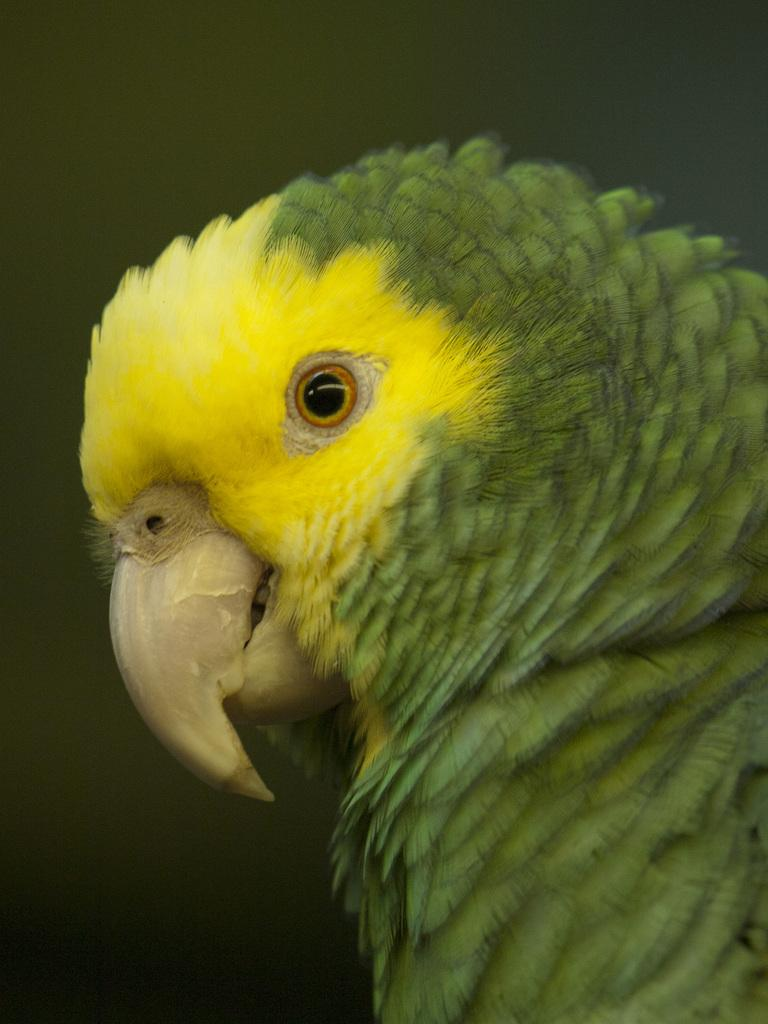What type of animal is present in the image? There is a budgerigar in the image. What type of vegetable is visible in the image? There are no vegetables present in the image; it features a budgerigar. Can you tell me how many frogs are in the image? There are no frogs present in the image; it features a budgerigar. 